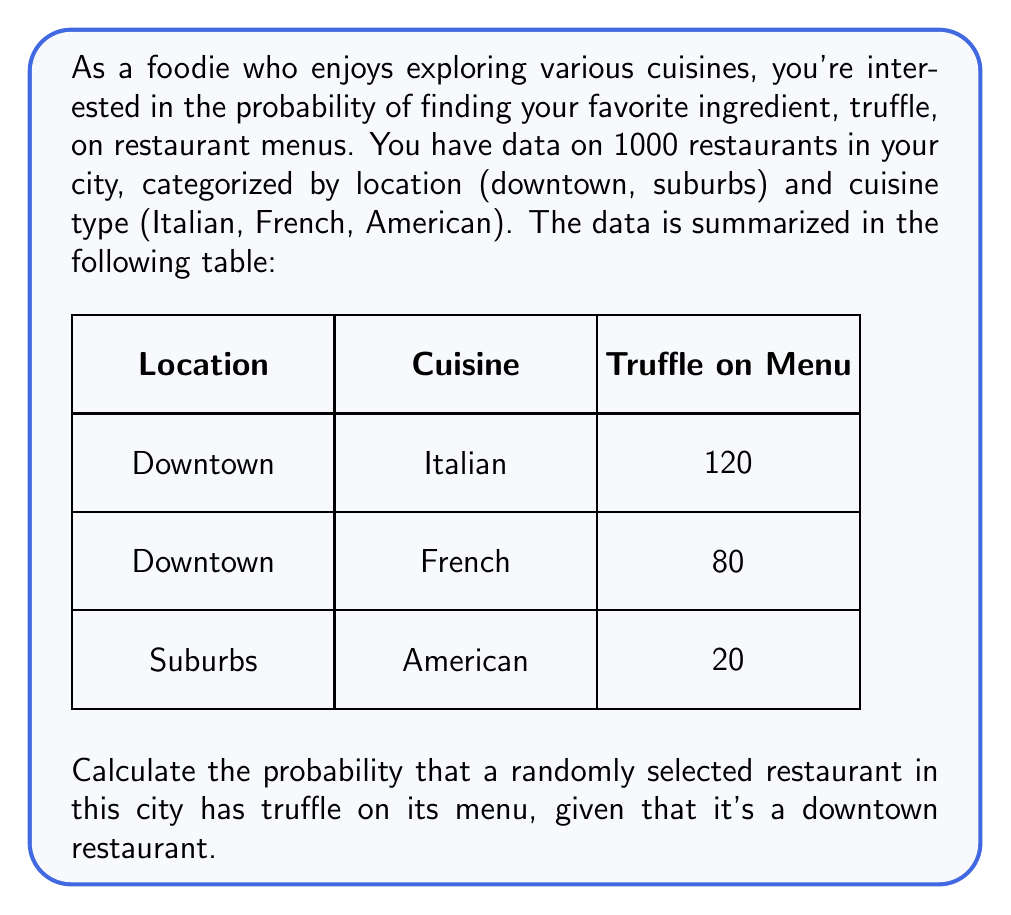Can you answer this question? Let's approach this step-by-step using conditional probability:

1) First, we need to identify the relevant probabilities:
   - P(T): Probability of a restaurant having truffle on the menu
   - P(D): Probability of a restaurant being downtown
   - P(T|D): Probability of a restaurant having truffle on the menu, given that it's downtown

2) We're asked to find P(T|D), which is given by the formula:

   $$P(T|D) = \frac{P(T \cap D)}{P(D)}$$

3) From the data:
   - Total restaurants: 1000
   - Downtown restaurants with truffle: 120 + 80 = 200
   - Total downtown restaurants: 200 + (1000 - 200 - 20) = 980

4) Calculate P(T ∩ D):
   $$P(T \cap D) = \frac{200}{1000} = 0.2$$

5) Calculate P(D):
   $$P(D) = \frac{980}{1000} = 0.98$$

6) Now we can calculate P(T|D):
   $$P(T|D) = \frac{P(T \cap D)}{P(D)} = \frac{0.2}{0.98} \approx 0.2041$$

Therefore, the probability of a randomly selected downtown restaurant having truffle on its menu is approximately 0.2041 or 20.41%.
Answer: 0.2041 